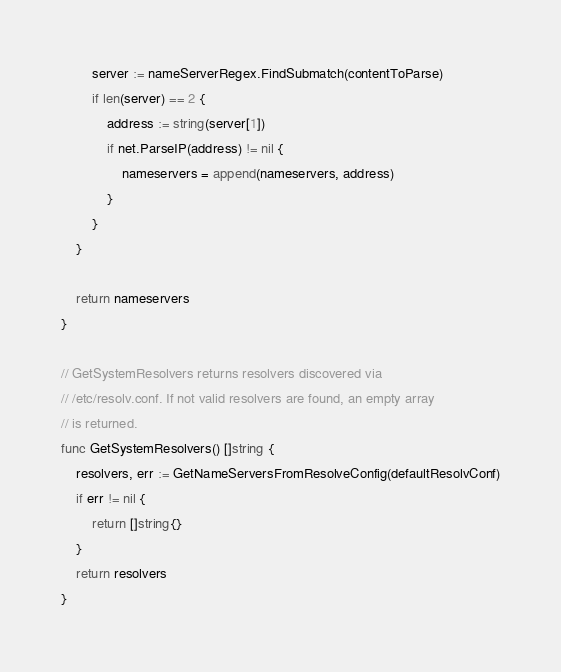Convert code to text. <code><loc_0><loc_0><loc_500><loc_500><_Go_>
		server := nameServerRegex.FindSubmatch(contentToParse)
		if len(server) == 2 {
			address := string(server[1])
			if net.ParseIP(address) != nil {
				nameservers = append(nameservers, address)
			}
		}
	}

	return nameservers
}

// GetSystemResolvers returns resolvers discovered via
// /etc/resolv.conf. If not valid resolvers are found, an empty array
// is returned.
func GetSystemResolvers() []string {
	resolvers, err := GetNameServersFromResolveConfig(defaultResolvConf)
	if err != nil {
		return []string{}
	}
	return resolvers
}
</code> 